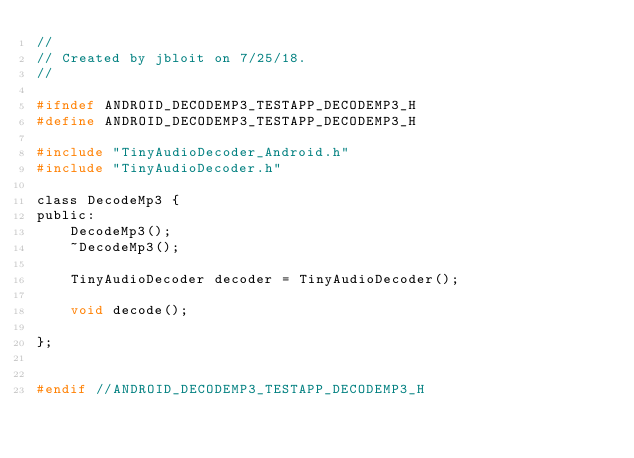Convert code to text. <code><loc_0><loc_0><loc_500><loc_500><_C_>//
// Created by jbloit on 7/25/18.
//

#ifndef ANDROID_DECODEMP3_TESTAPP_DECODEMP3_H
#define ANDROID_DECODEMP3_TESTAPP_DECODEMP3_H

#include "TinyAudioDecoder_Android.h"
#include "TinyAudioDecoder.h"

class DecodeMp3 {
public:
    DecodeMp3();
    ~DecodeMp3();

    TinyAudioDecoder decoder = TinyAudioDecoder();

    void decode();

};


#endif //ANDROID_DECODEMP3_TESTAPP_DECODEMP3_H
</code> 